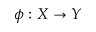Convert formula to latex. <formula><loc_0><loc_0><loc_500><loc_500>\phi \colon X \rightarrow Y</formula> 